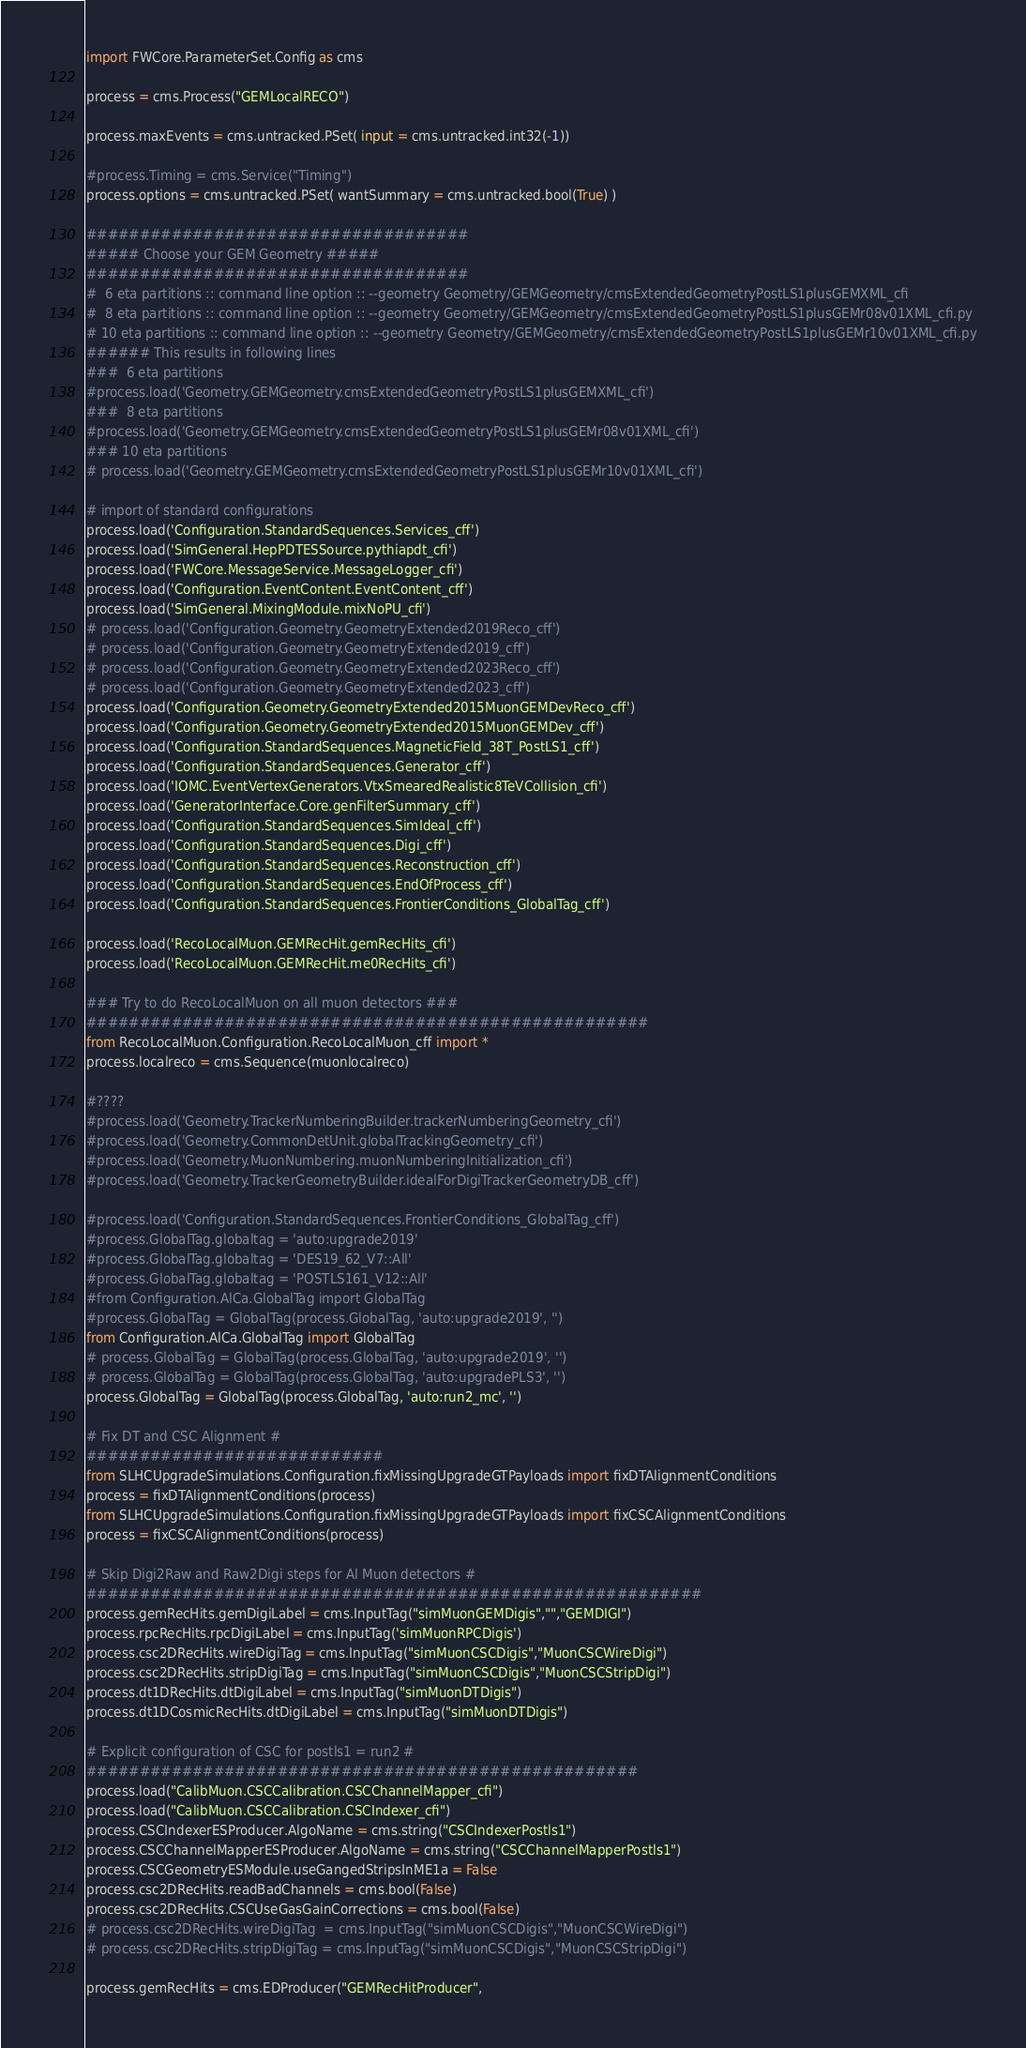<code> <loc_0><loc_0><loc_500><loc_500><_Python_>import FWCore.ParameterSet.Config as cms

process = cms.Process("GEMLocalRECO")

process.maxEvents = cms.untracked.PSet( input = cms.untracked.int32(-1))

#process.Timing = cms.Service("Timing")
process.options = cms.untracked.PSet( wantSummary = cms.untracked.bool(True) )

####################################
##### Choose your GEM Geometry #####
####################################
#  6 eta partitions :: command line option :: --geometry Geometry/GEMGeometry/cmsExtendedGeometryPostLS1plusGEMXML_cfi
#  8 eta partitions :: command line option :: --geometry Geometry/GEMGeometry/cmsExtendedGeometryPostLS1plusGEMr08v01XML_cfi.py
# 10 eta partitions :: command line option :: --geometry Geometry/GEMGeometry/cmsExtendedGeometryPostLS1plusGEMr10v01XML_cfi.py
###### This results in following lines
###  6 eta partitions
#process.load('Geometry.GEMGeometry.cmsExtendedGeometryPostLS1plusGEMXML_cfi')
###  8 eta partitions
#process.load('Geometry.GEMGeometry.cmsExtendedGeometryPostLS1plusGEMr08v01XML_cfi')
### 10 eta partitions
# process.load('Geometry.GEMGeometry.cmsExtendedGeometryPostLS1plusGEMr10v01XML_cfi')          

# import of standard configurations
process.load('Configuration.StandardSequences.Services_cff')
process.load('SimGeneral.HepPDTESSource.pythiapdt_cfi')
process.load('FWCore.MessageService.MessageLogger_cfi')
process.load('Configuration.EventContent.EventContent_cff')
process.load('SimGeneral.MixingModule.mixNoPU_cfi')
# process.load('Configuration.Geometry.GeometryExtended2019Reco_cff')
# process.load('Configuration.Geometry.GeometryExtended2019_cff')
# process.load('Configuration.Geometry.GeometryExtended2023Reco_cff')
# process.load('Configuration.Geometry.GeometryExtended2023_cff')
process.load('Configuration.Geometry.GeometryExtended2015MuonGEMDevReco_cff')
process.load('Configuration.Geometry.GeometryExtended2015MuonGEMDev_cff')
process.load('Configuration.StandardSequences.MagneticField_38T_PostLS1_cff')
process.load('Configuration.StandardSequences.Generator_cff')
process.load('IOMC.EventVertexGenerators.VtxSmearedRealistic8TeVCollision_cfi')
process.load('GeneratorInterface.Core.genFilterSummary_cff')
process.load('Configuration.StandardSequences.SimIdeal_cff')
process.load('Configuration.StandardSequences.Digi_cff')
process.load('Configuration.StandardSequences.Reconstruction_cff')
process.load('Configuration.StandardSequences.EndOfProcess_cff')
process.load('Configuration.StandardSequences.FrontierConditions_GlobalTag_cff')

process.load('RecoLocalMuon.GEMRecHit.gemRecHits_cfi')
process.load('RecoLocalMuon.GEMRecHit.me0RecHits_cfi')

### Try to do RecoLocalMuon on all muon detectors ###
#####################################################
from RecoLocalMuon.Configuration.RecoLocalMuon_cff import *
process.localreco = cms.Sequence(muonlocalreco)

#????
#process.load('Geometry.TrackerNumberingBuilder.trackerNumberingGeometry_cfi')
#process.load('Geometry.CommonDetUnit.globalTrackingGeometry_cfi')
#process.load('Geometry.MuonNumbering.muonNumberingInitialization_cfi')
#process.load('Geometry.TrackerGeometryBuilder.idealForDigiTrackerGeometryDB_cff')

#process.load('Configuration.StandardSequences.FrontierConditions_GlobalTag_cff')
#process.GlobalTag.globaltag = 'auto:upgrade2019'
#process.GlobalTag.globaltag = 'DES19_62_V7::All'
#process.GlobalTag.globaltag = 'POSTLS161_V12::All'
#from Configuration.AlCa.GlobalTag import GlobalTag
#process.GlobalTag = GlobalTag(process.GlobalTag, 'auto:upgrade2019', '')
from Configuration.AlCa.GlobalTag import GlobalTag
# process.GlobalTag = GlobalTag(process.GlobalTag, 'auto:upgrade2019', '')
# process.GlobalTag = GlobalTag(process.GlobalTag, 'auto:upgradePLS3', '')
process.GlobalTag = GlobalTag(process.GlobalTag, 'auto:run2_mc', '')

# Fix DT and CSC Alignment #
############################
from SLHCUpgradeSimulations.Configuration.fixMissingUpgradeGTPayloads import fixDTAlignmentConditions
process = fixDTAlignmentConditions(process)
from SLHCUpgradeSimulations.Configuration.fixMissingUpgradeGTPayloads import fixCSCAlignmentConditions
process = fixCSCAlignmentConditions(process)

# Skip Digi2Raw and Raw2Digi steps for Al Muon detectors #
##########################################################
process.gemRecHits.gemDigiLabel = cms.InputTag("simMuonGEMDigis","","GEMDIGI")
process.rpcRecHits.rpcDigiLabel = cms.InputTag('simMuonRPCDigis')
process.csc2DRecHits.wireDigiTag = cms.InputTag("simMuonCSCDigis","MuonCSCWireDigi")
process.csc2DRecHits.stripDigiTag = cms.InputTag("simMuonCSCDigis","MuonCSCStripDigi")
process.dt1DRecHits.dtDigiLabel = cms.InputTag("simMuonDTDigis")
process.dt1DCosmicRecHits.dtDigiLabel = cms.InputTag("simMuonDTDigis")

# Explicit configuration of CSC for postls1 = run2 #
####################################################
process.load("CalibMuon.CSCCalibration.CSCChannelMapper_cfi")
process.load("CalibMuon.CSCCalibration.CSCIndexer_cfi")
process.CSCIndexerESProducer.AlgoName = cms.string("CSCIndexerPostls1")
process.CSCChannelMapperESProducer.AlgoName = cms.string("CSCChannelMapperPostls1")
process.CSCGeometryESModule.useGangedStripsInME1a = False
process.csc2DRecHits.readBadChannels = cms.bool(False)
process.csc2DRecHits.CSCUseGasGainCorrections = cms.bool(False)
# process.csc2DRecHits.wireDigiTag  = cms.InputTag("simMuonCSCDigis","MuonCSCWireDigi")
# process.csc2DRecHits.stripDigiTag = cms.InputTag("simMuonCSCDigis","MuonCSCStripDigi")

process.gemRecHits = cms.EDProducer("GEMRecHitProducer",</code> 